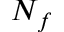<formula> <loc_0><loc_0><loc_500><loc_500>N _ { f }</formula> 